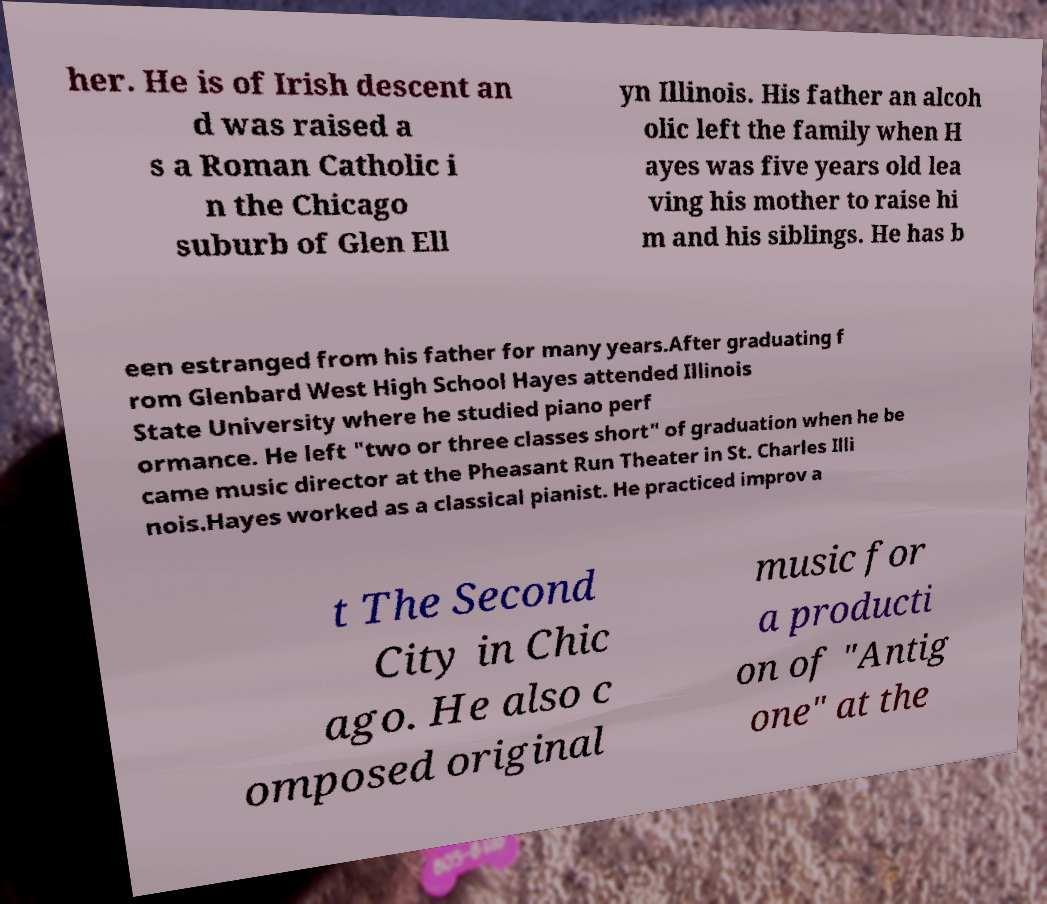What messages or text are displayed in this image? I need them in a readable, typed format. her. He is of Irish descent an d was raised a s a Roman Catholic i n the Chicago suburb of Glen Ell yn Illinois. His father an alcoh olic left the family when H ayes was five years old lea ving his mother to raise hi m and his siblings. He has b een estranged from his father for many years.After graduating f rom Glenbard West High School Hayes attended Illinois State University where he studied piano perf ormance. He left "two or three classes short" of graduation when he be came music director at the Pheasant Run Theater in St. Charles Illi nois.Hayes worked as a classical pianist. He practiced improv a t The Second City in Chic ago. He also c omposed original music for a producti on of "Antig one" at the 